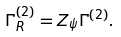<formula> <loc_0><loc_0><loc_500><loc_500>\Gamma ^ { ( 2 ) } _ { R } = Z _ { \psi } \Gamma ^ { ( 2 ) } .</formula> 